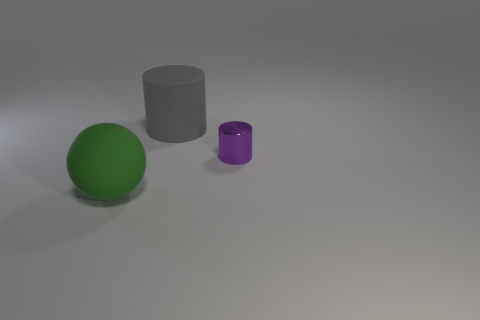Is the number of small cylinders in front of the sphere less than the number of big gray matte objects in front of the rubber cylinder? Indeed, the number of small cylinders in front of the sphere, which is one, is not less than the number of big gray matte objects, seeing as there is only one such object in the scene, positioned in front of the rubber cylinder. So the correct answer is that both quantities are equal, not less. 